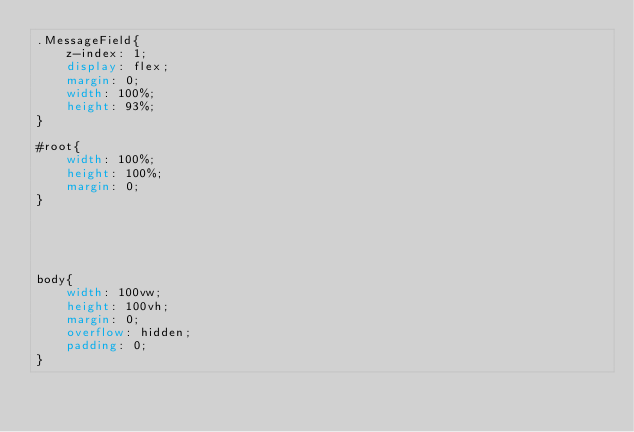Convert code to text. <code><loc_0><loc_0><loc_500><loc_500><_CSS_>.MessageField{
    z-index: 1; 
    display: flex;
    margin: 0; 
    width: 100%;
    height: 93%;
}

#root{
    width: 100%; 
    height: 100%; 
    margin: 0; 
}





body{
    width: 100vw;
    height: 100vh;
    margin: 0; 
    overflow: hidden;
    padding: 0; 
}</code> 